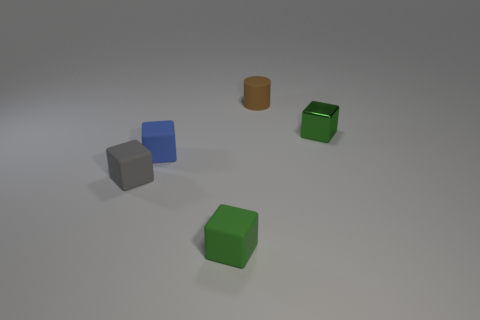Can you tell me what colors the objects in the image have? Certainly! There are four objects in the image, each with a distinct color. One is green, one is blue, one is gray, and the last one is a shade of brown or orange. 